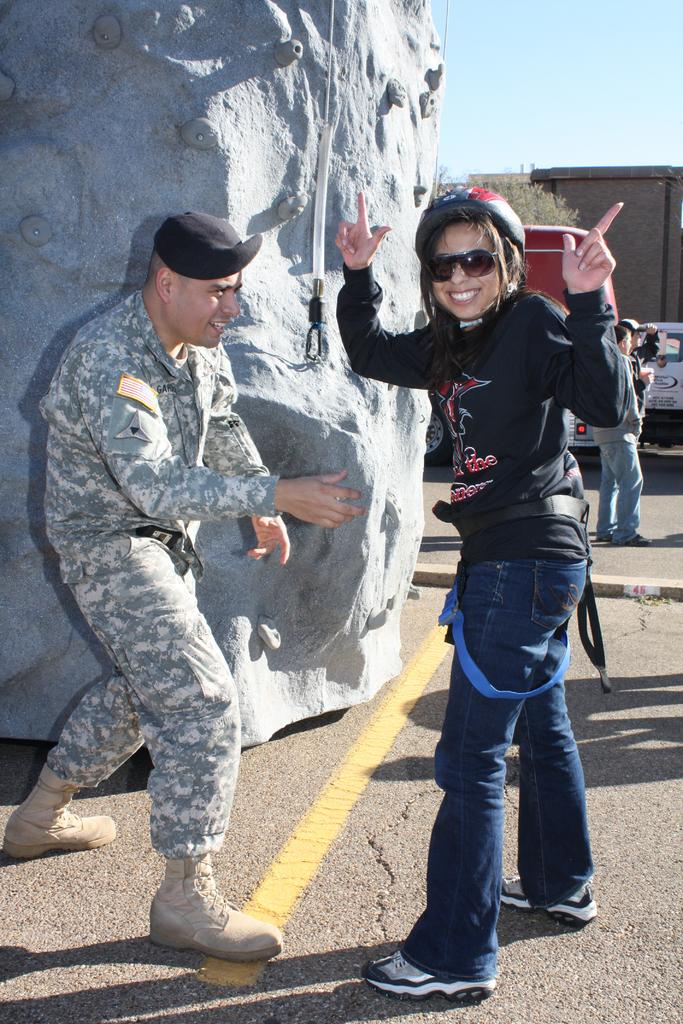How many people are in the image? There are people in the image, but the exact number is not specified. What type of vehicle is in the image? There is a vehicle in the image, but the specific type is not mentioned. What structures are visible in the image? There are buildings in the image. What natural elements are present in the image? There is a tree and a rock in the image. What part of the environment can be seen in the image? The sky is visible in the image. What protective gear is the person in the front wearing? The person in the front of the image is wearing a helmet and goggles. What is the facial expression of the person in the front? The person in the front of the image is smiling. Who is wearing the crown in the image? There is no crown present in the image. What type of stone is being smashed by the person in the image? There is no stone or smashing activity depicted in the image. 